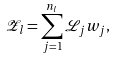<formula> <loc_0><loc_0><loc_500><loc_500>\mathcal { Z } _ { l } = \sum _ { j = 1 } ^ { n _ { l } } \mathcal { L } _ { j } w _ { j } ,</formula> 